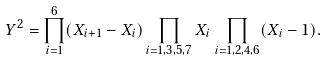<formula> <loc_0><loc_0><loc_500><loc_500>Y ^ { 2 } = \prod _ { i = 1 } ^ { 6 } ( X _ { i + 1 } - X _ { i } ) \prod _ { i = 1 , 3 , 5 , 7 } X _ { i } \prod _ { i = 1 , 2 , 4 , 6 } ( X _ { i } - 1 ) .</formula> 